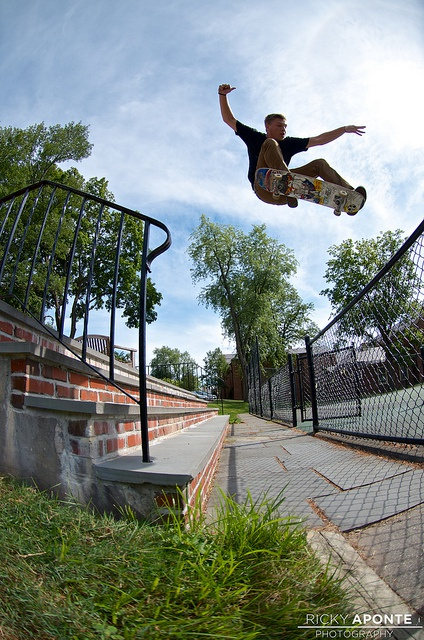Describe the objects in this image and their specific colors. I can see people in darkgray, black, maroon, and gray tones and skateboard in darkgray, gray, black, olive, and maroon tones in this image. 